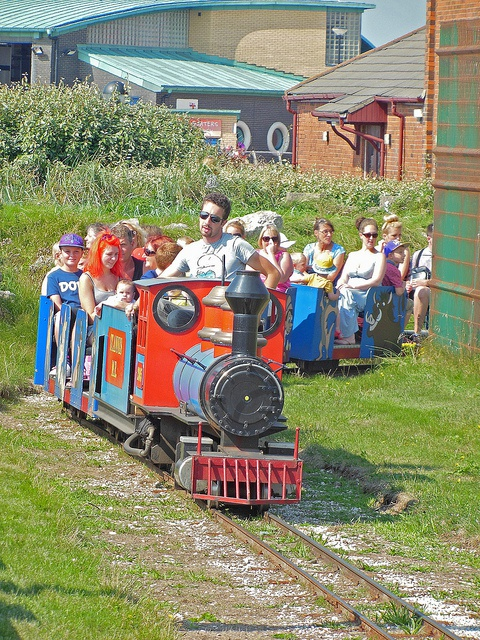Describe the objects in this image and their specific colors. I can see train in darkgray, gray, black, and red tones, people in darkgray, brown, white, olive, and gray tones, people in darkgray, white, brown, and gray tones, people in darkgray, white, and gray tones, and people in darkgray, white, brown, and gray tones in this image. 